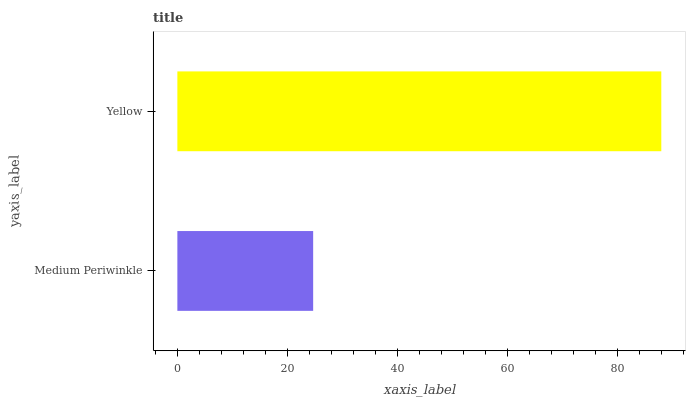Is Medium Periwinkle the minimum?
Answer yes or no. Yes. Is Yellow the maximum?
Answer yes or no. Yes. Is Yellow the minimum?
Answer yes or no. No. Is Yellow greater than Medium Periwinkle?
Answer yes or no. Yes. Is Medium Periwinkle less than Yellow?
Answer yes or no. Yes. Is Medium Periwinkle greater than Yellow?
Answer yes or no. No. Is Yellow less than Medium Periwinkle?
Answer yes or no. No. Is Yellow the high median?
Answer yes or no. Yes. Is Medium Periwinkle the low median?
Answer yes or no. Yes. Is Medium Periwinkle the high median?
Answer yes or no. No. Is Yellow the low median?
Answer yes or no. No. 